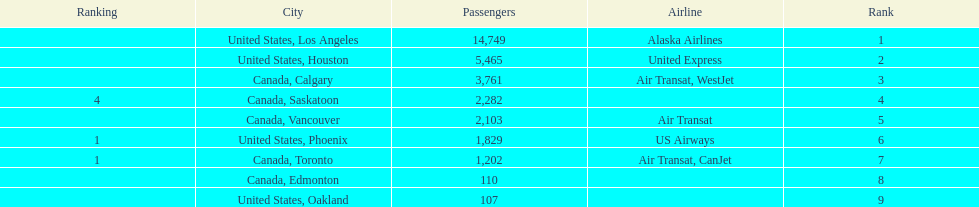What is the average number of passengers in the united states? 5537.5. 